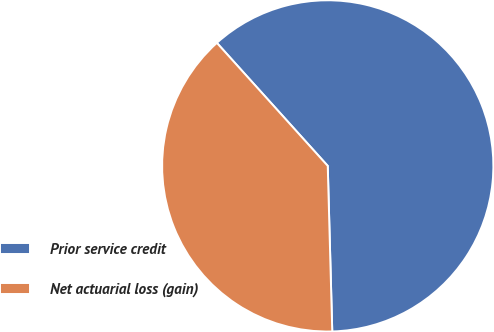<chart> <loc_0><loc_0><loc_500><loc_500><pie_chart><fcel>Prior service credit<fcel>Net actuarial loss (gain)<nl><fcel>61.24%<fcel>38.76%<nl></chart> 